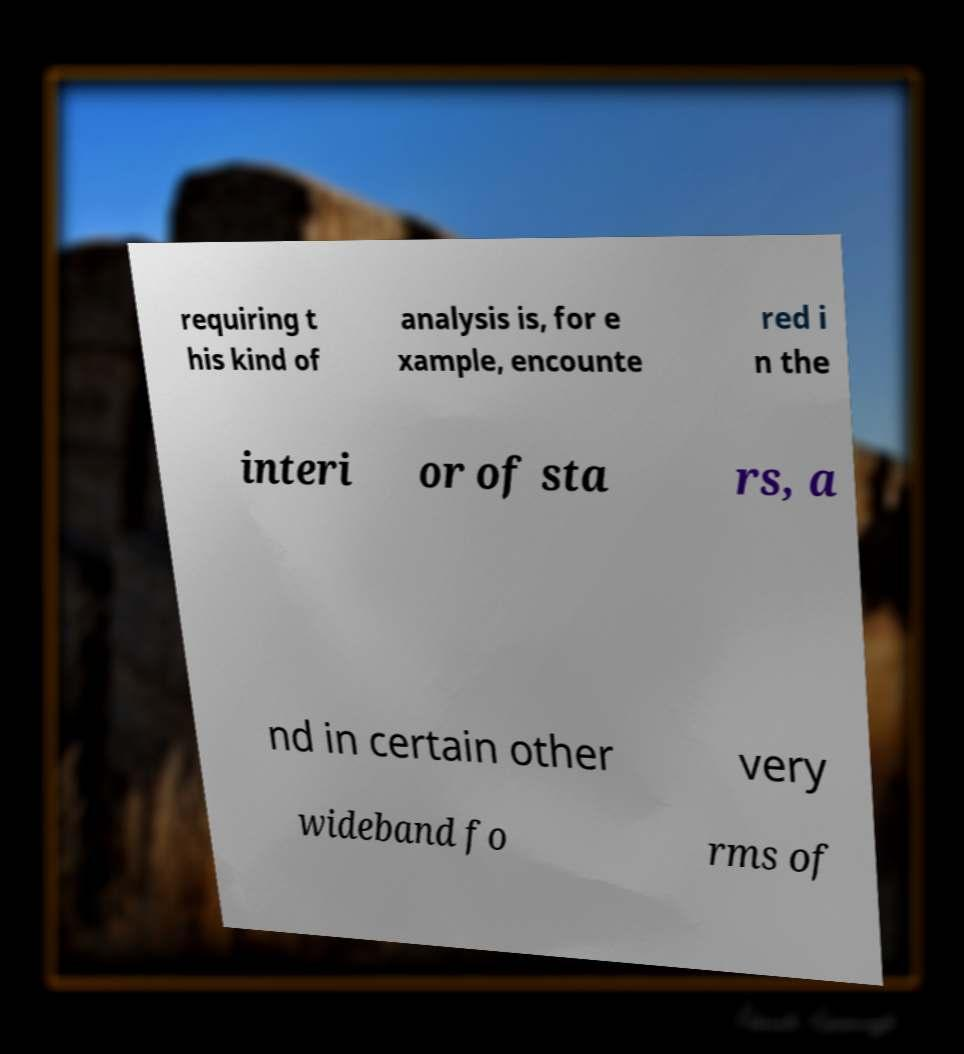For documentation purposes, I need the text within this image transcribed. Could you provide that? requiring t his kind of analysis is, for e xample, encounte red i n the interi or of sta rs, a nd in certain other very wideband fo rms of 